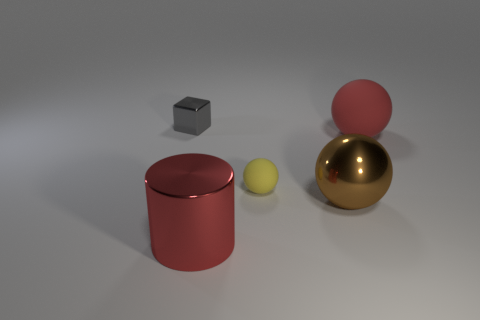Subtract all rubber balls. How many balls are left? 1 Add 3 yellow objects. How many objects exist? 8 Subtract all spheres. How many objects are left? 2 Subtract all red shiny things. Subtract all big purple metallic cylinders. How many objects are left? 4 Add 3 red shiny objects. How many red shiny objects are left? 4 Add 2 small matte spheres. How many small matte spheres exist? 3 Subtract 1 yellow spheres. How many objects are left? 4 